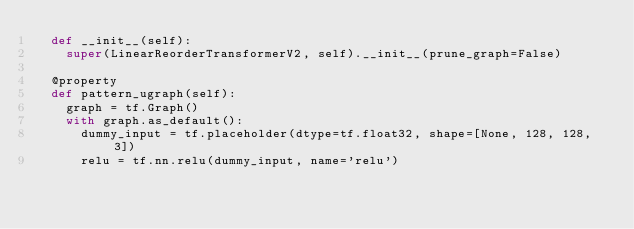<code> <loc_0><loc_0><loc_500><loc_500><_Python_>  def __init__(self):
    super(LinearReorderTransformerV2, self).__init__(prune_graph=False)

  @property
  def pattern_ugraph(self):
    graph = tf.Graph()
    with graph.as_default():
      dummy_input = tf.placeholder(dtype=tf.float32, shape=[None, 128, 128, 3])
      relu = tf.nn.relu(dummy_input, name='relu')</code> 